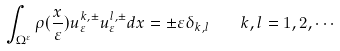Convert formula to latex. <formula><loc_0><loc_0><loc_500><loc_500>\int _ { \Omega ^ { \varepsilon } } \rho ( \frac { x } { \varepsilon } ) u _ { \varepsilon } ^ { k , \pm } u _ { \varepsilon } ^ { l , \pm } d x = \pm \varepsilon \delta _ { k , l } \quad k , l = 1 , 2 , \cdots</formula> 